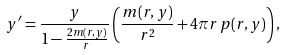Convert formula to latex. <formula><loc_0><loc_0><loc_500><loc_500>y ^ { \prime } = \frac { y } { 1 - \frac { 2 m ( r , y ) } { r } } \left ( \frac { m ( r , y ) } { r ^ { 2 } } + 4 \pi r \, p ( r , y ) \right ) ,</formula> 